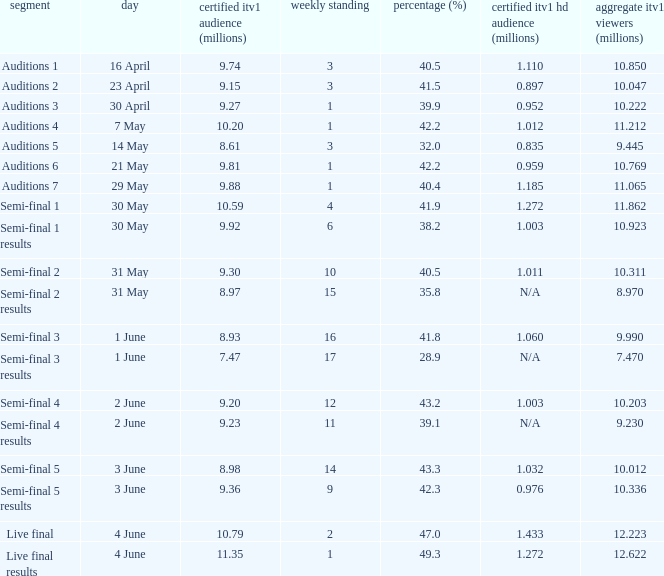What was the total ITV1 viewers in millions for the episode with a share (%) of 28.9?  7.47. 